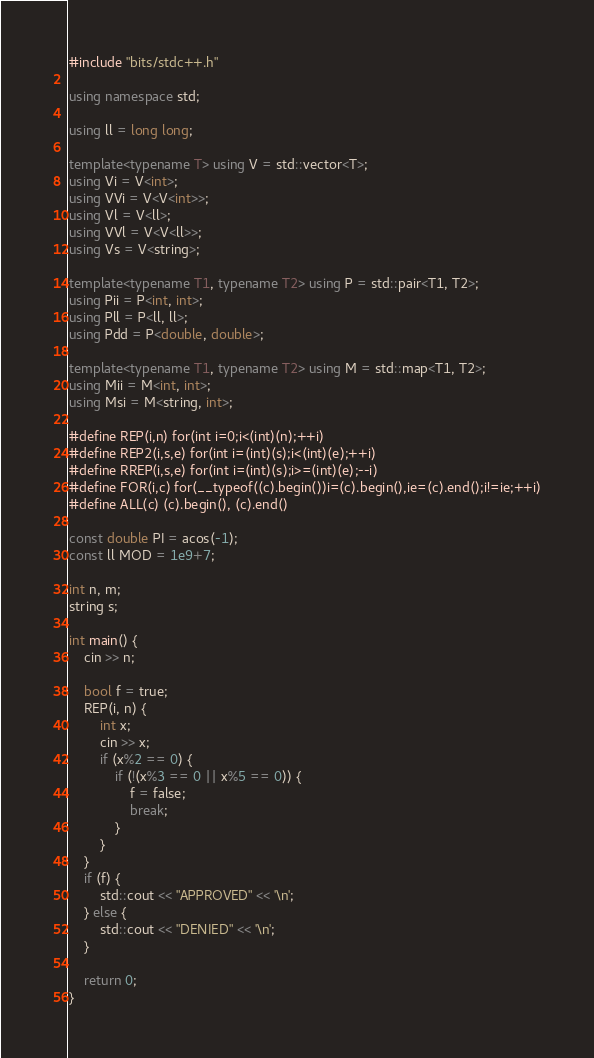<code> <loc_0><loc_0><loc_500><loc_500><_C++_>#include "bits/stdc++.h"

using namespace std;

using ll = long long;

template<typename T> using V = std::vector<T>;
using Vi = V<int>;
using VVi = V<V<int>>;
using Vl = V<ll>;
using VVl = V<V<ll>>;
using Vs = V<string>;

template<typename T1, typename T2> using P = std::pair<T1, T2>;
using Pii = P<int, int>;
using Pll = P<ll, ll>;
using Pdd = P<double, double>;

template<typename T1, typename T2> using M = std::map<T1, T2>;
using Mii = M<int, int>;
using Msi = M<string, int>;

#define REP(i,n) for(int i=0;i<(int)(n);++i)
#define REP2(i,s,e) for(int i=(int)(s);i<(int)(e);++i)
#define RREP(i,s,e) for(int i=(int)(s);i>=(int)(e);--i)
#define FOR(i,c) for(__typeof((c).begin())i=(c).begin(),ie=(c).end();i!=ie;++i)
#define ALL(c) (c).begin(), (c).end()

const double PI = acos(-1);
const ll MOD = 1e9+7;

int n, m;
string s;

int main() {
    cin >> n;

    bool f = true;
    REP(i, n) {
        int x;
        cin >> x;
        if (x%2 == 0) {
            if (!(x%3 == 0 || x%5 == 0)) {
                f = false;
                break;
            }
        }
    }
    if (f) {
        std::cout << "APPROVED" << '\n';
    } else {
        std::cout << "DENIED" << '\n';
    }

    return 0;
}
</code> 